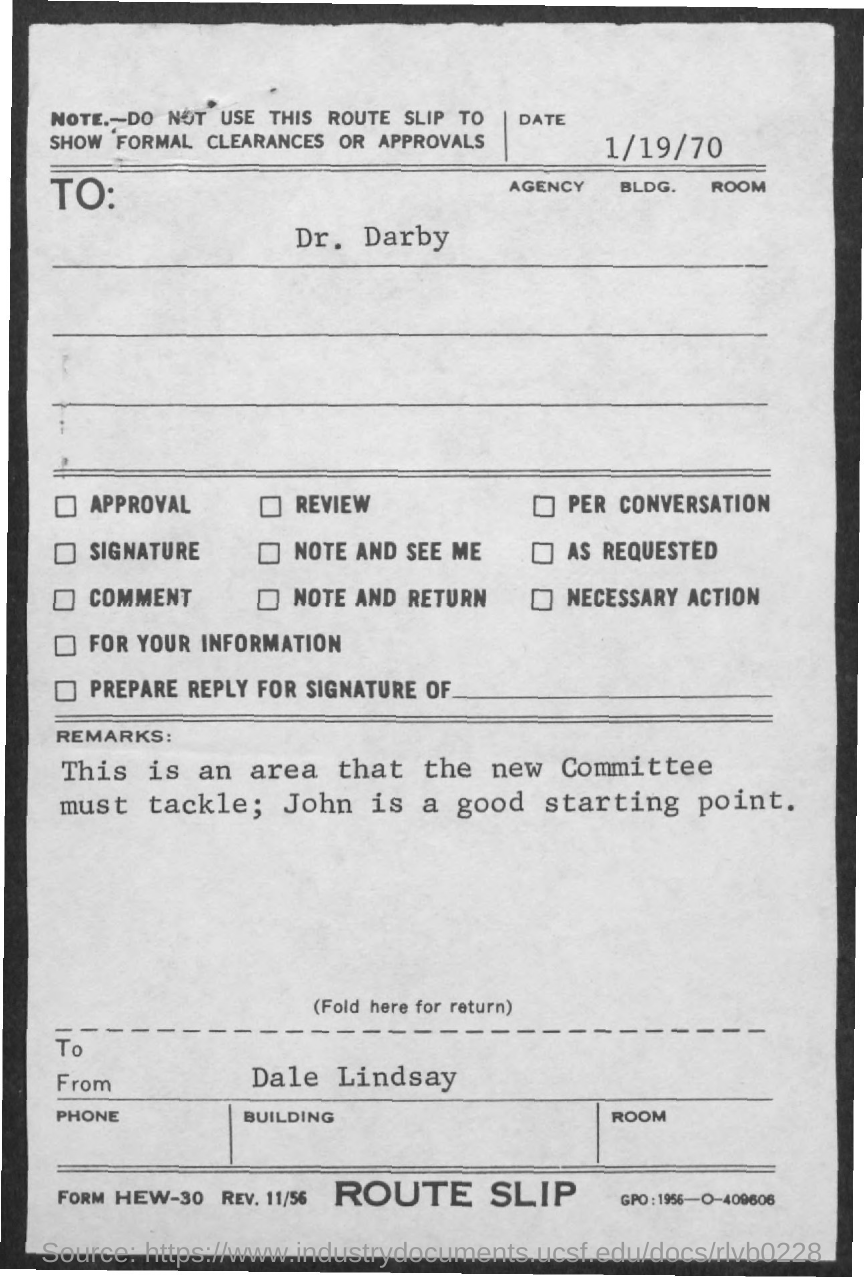Draw attention to some important aspects in this diagram. John is a good starting point. The recipient of the message is Dr. Darby. The sender of this message is Dale Lindsay. 